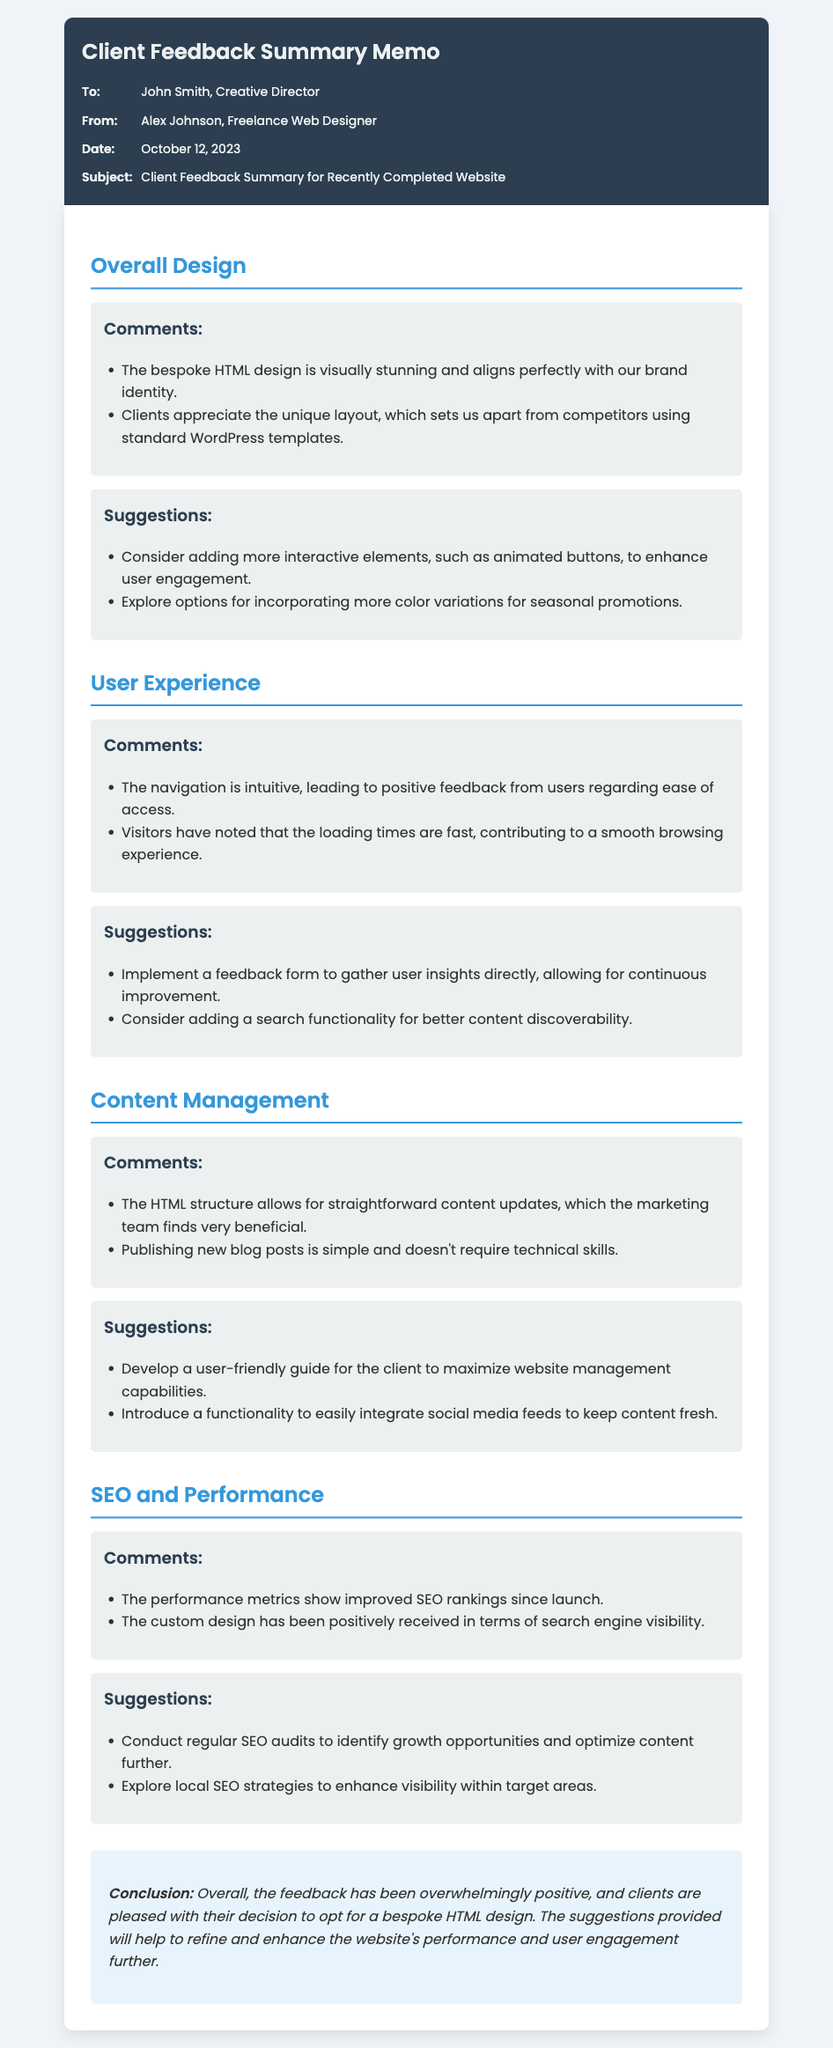What is the title of the memo? The title of the memo is displayed prominently at the top of the document.
Answer: Client Feedback Summary Memo Who is the Creative Director addressed in the memo? The memo lists the recipient's name as part of the meta information.
Answer: John Smith What date was the memo sent? The date is included in the meta information section of the memo.
Answer: October 12, 2023 What are the clients pleased with? The conclusion summarizes the overall sentiment expressed in the feedback.
Answer: Bespoke HTML design What suggestion was made for enhancing user engagement? This suggestion can be found in the "Overall Design" suggestions section.
Answer: Animated buttons How did clients find the website's navigation? This feedback is found in the "User Experience" comments section.
Answer: Intuitive What was noted about the performance metrics? The comments in the "SEO and Performance" section address this issue.
Answer: Improved SEO rankings What is a suggested addition for the content management section? This can be found in the "Content Management" suggestions section.
Answer: User-friendly guide What does the memo suggest to enhance local visibility? This suggestion is located in the "SEO and Performance" suggestions section.
Answer: Local SEO strategies 